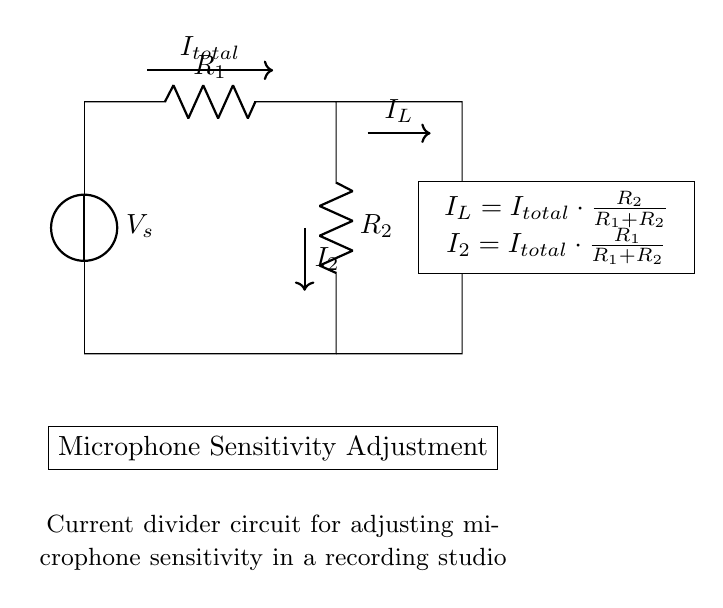What is the total current in the circuit? The total current in the circuit, denoted as I_total, is represented by the arrow labeled I_total at the top of the circuit diagram. It shows the primary flow of current flowing into the series arrangement of resistors.
Answer: I_total What are the values of R1 and R2? The resistors R1 and R2 are shown connected in series in the circuit diagram, but the specific values for these resistors are not provided in the diagram. However, R1 is positioned before R2 in the circuit from the voltage source perspective.
Answer: Not specified What is the current through R2? The current through R2, denoted as I2 in the diagram, can be found using the current divider formula: I2 = I_total * (R1 / (R1 + R2)). This shows how the total current is split between the two resistors, R1 and R2.
Answer: I_total * (R1 / (R1 + R2)) What does the symbol V_s represent? The symbol V_s in the circuit diagram represents the voltage source that supplies power to the circuit. It is labeled clearly at the top of the diagram.
Answer: Voltage source How does the current division occur in the circuit? The current division occurs due to the presence of two resistors in parallel, which allows the total current to be split in inverse proportion to the resistance values: I_L = I_total * (R2 / (R1 + R2)) for the load resistor RL and I2 for R1. Thus, the distribution of current depends on the values of R1 and R2.
Answer: Through resistance values What is the purpose of this current divider circuit? The purpose of the current divider circuit illustrated in the diagram is to adjust the sensitivity of a microphone in a recording studio. By controlling the current through the load resistor RL, the input to the microphone can be effectively altered, impacting the audio sensitivity.
Answer: Adjust microphone sensitivity 